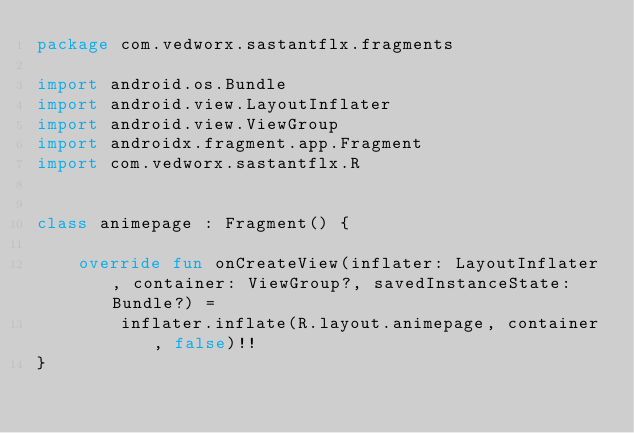Convert code to text. <code><loc_0><loc_0><loc_500><loc_500><_Kotlin_>package com.vedworx.sastantflx.fragments

import android.os.Bundle
import android.view.LayoutInflater
import android.view.ViewGroup
import androidx.fragment.app.Fragment
import com.vedworx.sastantflx.R


class animepage : Fragment() {

    override fun onCreateView(inflater: LayoutInflater, container: ViewGroup?, savedInstanceState: Bundle?) =
        inflater.inflate(R.layout.animepage, container, false)!!
}</code> 